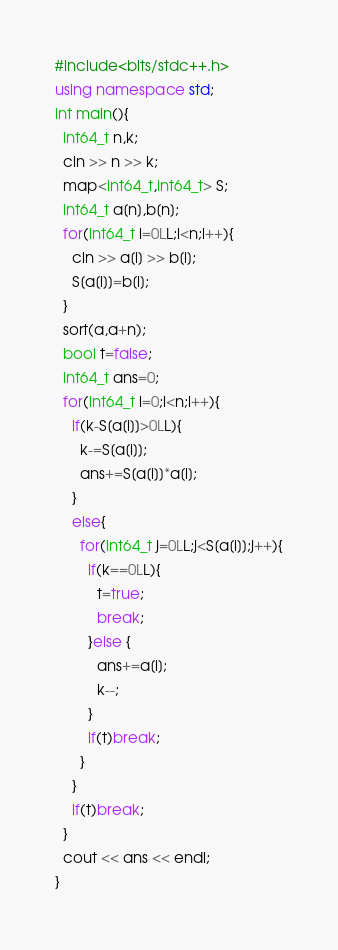<code> <loc_0><loc_0><loc_500><loc_500><_C++_>#include<bits/stdc++.h>
using namespace std;
int main(){
  int64_t n,k;
  cin >> n >> k;
  map<int64_t,int64_t> S;
  int64_t a[n],b[n];
  for(int64_t i=0LL;i<n;i++){
    cin >> a[i] >> b[i];
    S[a[i]]=b[i];
  }
  sort(a,a+n);
  bool t=false;
  int64_t ans=0;
  for(int64_t i=0;i<n;i++){
    if(k-S[a[i]]>0LL){
      k-=S[a[i]];
      ans+=S[a[i]]*a[i];
    }
    else{
      for(int64_t j=0LL;j<S[a[i]];j++){
        if(k==0LL){
          t=true;
          break;
        }else {
          ans+=a[i];
          k--;
        }
        if(t)break;
      }
    }
    if(t)break;
  }
  cout << ans << endl;
}</code> 